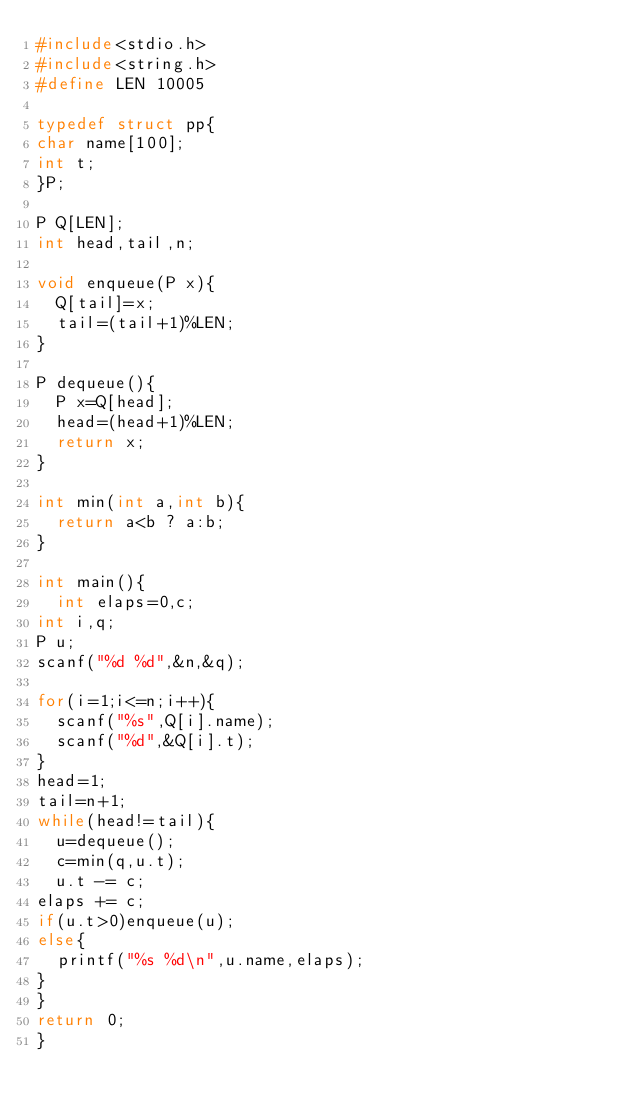<code> <loc_0><loc_0><loc_500><loc_500><_C_>#include<stdio.h>
#include<string.h>
#define LEN 10005

typedef struct pp{
char name[100];
int t;
}P;

P Q[LEN];
int head,tail,n;

void enqueue(P x){
  Q[tail]=x;
  tail=(tail+1)%LEN;
}

P dequeue(){
  P x=Q[head];
  head=(head+1)%LEN;
  return x;
}

int min(int a,int b){
  return a<b ? a:b;
}

int main(){
  int elaps=0,c;
int i,q;
P u;
scanf("%d %d",&n,&q);

for(i=1;i<=n;i++){
  scanf("%s",Q[i].name);
  scanf("%d",&Q[i].t);
}
head=1;
tail=n+1;
while(head!=tail){
  u=dequeue();
  c=min(q,u.t);
  u.t -= c;
elaps += c;
if(u.t>0)enqueue(u);
else{
  printf("%s %d\n",u.name,elaps);
}
}
return 0;
}

</code> 